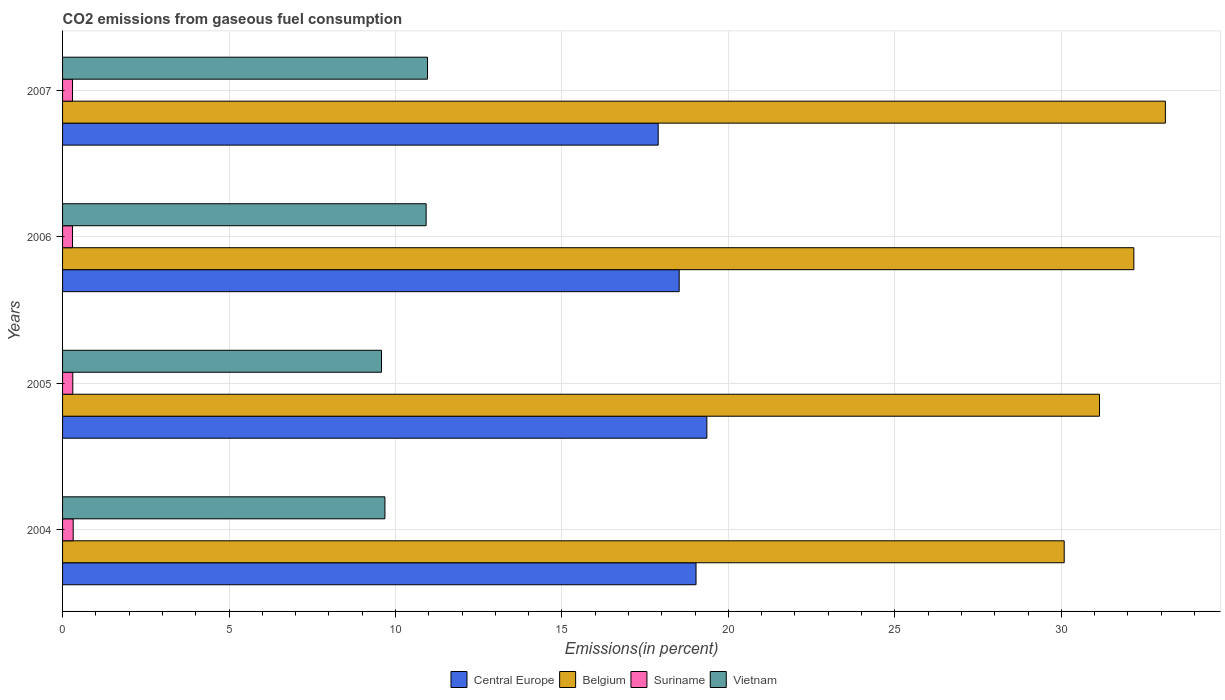How many groups of bars are there?
Your response must be concise. 4. How many bars are there on the 2nd tick from the top?
Provide a short and direct response. 4. What is the label of the 3rd group of bars from the top?
Your answer should be compact. 2005. In how many cases, is the number of bars for a given year not equal to the number of legend labels?
Your answer should be compact. 0. What is the total CO2 emitted in Belgium in 2006?
Your answer should be very brief. 32.18. Across all years, what is the maximum total CO2 emitted in Central Europe?
Make the answer very short. 19.35. Across all years, what is the minimum total CO2 emitted in Suriname?
Your answer should be compact. 0.3. What is the total total CO2 emitted in Suriname in the graph?
Your response must be concise. 1.22. What is the difference between the total CO2 emitted in Suriname in 2005 and that in 2006?
Make the answer very short. 0.01. What is the difference between the total CO2 emitted in Belgium in 2006 and the total CO2 emitted in Central Europe in 2005?
Your answer should be compact. 12.83. What is the average total CO2 emitted in Suriname per year?
Your answer should be very brief. 0.31. In the year 2007, what is the difference between the total CO2 emitted in Central Europe and total CO2 emitted in Belgium?
Keep it short and to the point. -15.23. What is the ratio of the total CO2 emitted in Central Europe in 2004 to that in 2006?
Provide a succinct answer. 1.03. Is the total CO2 emitted in Belgium in 2004 less than that in 2007?
Provide a short and direct response. Yes. What is the difference between the highest and the second highest total CO2 emitted in Suriname?
Offer a terse response. 0.01. What is the difference between the highest and the lowest total CO2 emitted in Central Europe?
Provide a short and direct response. 1.46. In how many years, is the total CO2 emitted in Vietnam greater than the average total CO2 emitted in Vietnam taken over all years?
Offer a very short reply. 2. Is the sum of the total CO2 emitted in Vietnam in 2005 and 2007 greater than the maximum total CO2 emitted in Suriname across all years?
Make the answer very short. Yes. Is it the case that in every year, the sum of the total CO2 emitted in Belgium and total CO2 emitted in Central Europe is greater than the sum of total CO2 emitted in Suriname and total CO2 emitted in Vietnam?
Your response must be concise. No. What does the 4th bar from the top in 2006 represents?
Provide a short and direct response. Central Europe. What does the 4th bar from the bottom in 2005 represents?
Keep it short and to the point. Vietnam. How many bars are there?
Give a very brief answer. 16. What is the difference between two consecutive major ticks on the X-axis?
Provide a short and direct response. 5. Are the values on the major ticks of X-axis written in scientific E-notation?
Make the answer very short. No. Does the graph contain any zero values?
Offer a very short reply. No. Does the graph contain grids?
Make the answer very short. Yes. What is the title of the graph?
Provide a succinct answer. CO2 emissions from gaseous fuel consumption. What is the label or title of the X-axis?
Keep it short and to the point. Emissions(in percent). What is the Emissions(in percent) of Central Europe in 2004?
Provide a short and direct response. 19.03. What is the Emissions(in percent) of Belgium in 2004?
Ensure brevity in your answer.  30.09. What is the Emissions(in percent) in Suriname in 2004?
Ensure brevity in your answer.  0.32. What is the Emissions(in percent) in Vietnam in 2004?
Make the answer very short. 9.68. What is the Emissions(in percent) in Central Europe in 2005?
Provide a succinct answer. 19.35. What is the Emissions(in percent) of Belgium in 2005?
Ensure brevity in your answer.  31.15. What is the Emissions(in percent) of Suriname in 2005?
Your answer should be compact. 0.31. What is the Emissions(in percent) in Vietnam in 2005?
Offer a very short reply. 9.58. What is the Emissions(in percent) of Central Europe in 2006?
Provide a succinct answer. 18.52. What is the Emissions(in percent) of Belgium in 2006?
Your response must be concise. 32.18. What is the Emissions(in percent) in Suriname in 2006?
Provide a succinct answer. 0.3. What is the Emissions(in percent) of Vietnam in 2006?
Your answer should be very brief. 10.92. What is the Emissions(in percent) of Central Europe in 2007?
Provide a succinct answer. 17.89. What is the Emissions(in percent) of Belgium in 2007?
Provide a short and direct response. 33.13. What is the Emissions(in percent) in Suriname in 2007?
Make the answer very short. 0.3. What is the Emissions(in percent) in Vietnam in 2007?
Offer a terse response. 10.96. Across all years, what is the maximum Emissions(in percent) in Central Europe?
Your answer should be compact. 19.35. Across all years, what is the maximum Emissions(in percent) of Belgium?
Your response must be concise. 33.13. Across all years, what is the maximum Emissions(in percent) in Suriname?
Keep it short and to the point. 0.32. Across all years, what is the maximum Emissions(in percent) in Vietnam?
Make the answer very short. 10.96. Across all years, what is the minimum Emissions(in percent) of Central Europe?
Offer a very short reply. 17.89. Across all years, what is the minimum Emissions(in percent) in Belgium?
Your answer should be compact. 30.09. Across all years, what is the minimum Emissions(in percent) in Suriname?
Provide a succinct answer. 0.3. Across all years, what is the minimum Emissions(in percent) in Vietnam?
Your answer should be very brief. 9.58. What is the total Emissions(in percent) in Central Europe in the graph?
Offer a terse response. 74.8. What is the total Emissions(in percent) of Belgium in the graph?
Your answer should be very brief. 126.54. What is the total Emissions(in percent) of Suriname in the graph?
Keep it short and to the point. 1.22. What is the total Emissions(in percent) of Vietnam in the graph?
Offer a terse response. 41.15. What is the difference between the Emissions(in percent) of Central Europe in 2004 and that in 2005?
Make the answer very short. -0.32. What is the difference between the Emissions(in percent) of Belgium in 2004 and that in 2005?
Your response must be concise. -1.06. What is the difference between the Emissions(in percent) in Suriname in 2004 and that in 2005?
Provide a succinct answer. 0.01. What is the difference between the Emissions(in percent) of Vietnam in 2004 and that in 2005?
Provide a succinct answer. 0.1. What is the difference between the Emissions(in percent) of Central Europe in 2004 and that in 2006?
Ensure brevity in your answer.  0.51. What is the difference between the Emissions(in percent) of Belgium in 2004 and that in 2006?
Make the answer very short. -2.09. What is the difference between the Emissions(in percent) in Suriname in 2004 and that in 2006?
Your response must be concise. 0.02. What is the difference between the Emissions(in percent) of Vietnam in 2004 and that in 2006?
Make the answer very short. -1.24. What is the difference between the Emissions(in percent) of Central Europe in 2004 and that in 2007?
Provide a succinct answer. 1.14. What is the difference between the Emissions(in percent) in Belgium in 2004 and that in 2007?
Your answer should be very brief. -3.04. What is the difference between the Emissions(in percent) of Vietnam in 2004 and that in 2007?
Keep it short and to the point. -1.28. What is the difference between the Emissions(in percent) in Central Europe in 2005 and that in 2006?
Offer a terse response. 0.83. What is the difference between the Emissions(in percent) in Belgium in 2005 and that in 2006?
Your response must be concise. -1.03. What is the difference between the Emissions(in percent) of Suriname in 2005 and that in 2006?
Your answer should be compact. 0.01. What is the difference between the Emissions(in percent) in Vietnam in 2005 and that in 2006?
Keep it short and to the point. -1.34. What is the difference between the Emissions(in percent) in Central Europe in 2005 and that in 2007?
Provide a succinct answer. 1.46. What is the difference between the Emissions(in percent) of Belgium in 2005 and that in 2007?
Provide a succinct answer. -1.98. What is the difference between the Emissions(in percent) of Suriname in 2005 and that in 2007?
Keep it short and to the point. 0.01. What is the difference between the Emissions(in percent) of Vietnam in 2005 and that in 2007?
Your response must be concise. -1.38. What is the difference between the Emissions(in percent) of Central Europe in 2006 and that in 2007?
Make the answer very short. 0.63. What is the difference between the Emissions(in percent) in Belgium in 2006 and that in 2007?
Offer a terse response. -0.95. What is the difference between the Emissions(in percent) of Suriname in 2006 and that in 2007?
Your response must be concise. 0. What is the difference between the Emissions(in percent) of Vietnam in 2006 and that in 2007?
Keep it short and to the point. -0.04. What is the difference between the Emissions(in percent) in Central Europe in 2004 and the Emissions(in percent) in Belgium in 2005?
Your answer should be very brief. -12.12. What is the difference between the Emissions(in percent) of Central Europe in 2004 and the Emissions(in percent) of Suriname in 2005?
Provide a short and direct response. 18.72. What is the difference between the Emissions(in percent) of Central Europe in 2004 and the Emissions(in percent) of Vietnam in 2005?
Offer a terse response. 9.45. What is the difference between the Emissions(in percent) of Belgium in 2004 and the Emissions(in percent) of Suriname in 2005?
Your answer should be compact. 29.78. What is the difference between the Emissions(in percent) of Belgium in 2004 and the Emissions(in percent) of Vietnam in 2005?
Provide a short and direct response. 20.51. What is the difference between the Emissions(in percent) in Suriname in 2004 and the Emissions(in percent) in Vietnam in 2005?
Make the answer very short. -9.26. What is the difference between the Emissions(in percent) in Central Europe in 2004 and the Emissions(in percent) in Belgium in 2006?
Your response must be concise. -13.15. What is the difference between the Emissions(in percent) in Central Europe in 2004 and the Emissions(in percent) in Suriname in 2006?
Your response must be concise. 18.73. What is the difference between the Emissions(in percent) of Central Europe in 2004 and the Emissions(in percent) of Vietnam in 2006?
Your response must be concise. 8.11. What is the difference between the Emissions(in percent) in Belgium in 2004 and the Emissions(in percent) in Suriname in 2006?
Make the answer very short. 29.79. What is the difference between the Emissions(in percent) of Belgium in 2004 and the Emissions(in percent) of Vietnam in 2006?
Keep it short and to the point. 19.17. What is the difference between the Emissions(in percent) of Suriname in 2004 and the Emissions(in percent) of Vietnam in 2006?
Ensure brevity in your answer.  -10.6. What is the difference between the Emissions(in percent) of Central Europe in 2004 and the Emissions(in percent) of Belgium in 2007?
Make the answer very short. -14.1. What is the difference between the Emissions(in percent) in Central Europe in 2004 and the Emissions(in percent) in Suriname in 2007?
Offer a very short reply. 18.73. What is the difference between the Emissions(in percent) in Central Europe in 2004 and the Emissions(in percent) in Vietnam in 2007?
Make the answer very short. 8.07. What is the difference between the Emissions(in percent) in Belgium in 2004 and the Emissions(in percent) in Suriname in 2007?
Your answer should be very brief. 29.79. What is the difference between the Emissions(in percent) in Belgium in 2004 and the Emissions(in percent) in Vietnam in 2007?
Your answer should be very brief. 19.12. What is the difference between the Emissions(in percent) of Suriname in 2004 and the Emissions(in percent) of Vietnam in 2007?
Your answer should be very brief. -10.64. What is the difference between the Emissions(in percent) of Central Europe in 2005 and the Emissions(in percent) of Belgium in 2006?
Your answer should be very brief. -12.83. What is the difference between the Emissions(in percent) in Central Europe in 2005 and the Emissions(in percent) in Suriname in 2006?
Provide a short and direct response. 19.05. What is the difference between the Emissions(in percent) in Central Europe in 2005 and the Emissions(in percent) in Vietnam in 2006?
Your answer should be very brief. 8.43. What is the difference between the Emissions(in percent) of Belgium in 2005 and the Emissions(in percent) of Suriname in 2006?
Keep it short and to the point. 30.85. What is the difference between the Emissions(in percent) in Belgium in 2005 and the Emissions(in percent) in Vietnam in 2006?
Provide a short and direct response. 20.23. What is the difference between the Emissions(in percent) of Suriname in 2005 and the Emissions(in percent) of Vietnam in 2006?
Ensure brevity in your answer.  -10.61. What is the difference between the Emissions(in percent) in Central Europe in 2005 and the Emissions(in percent) in Belgium in 2007?
Make the answer very short. -13.77. What is the difference between the Emissions(in percent) of Central Europe in 2005 and the Emissions(in percent) of Suriname in 2007?
Give a very brief answer. 19.05. What is the difference between the Emissions(in percent) of Central Europe in 2005 and the Emissions(in percent) of Vietnam in 2007?
Offer a terse response. 8.39. What is the difference between the Emissions(in percent) of Belgium in 2005 and the Emissions(in percent) of Suriname in 2007?
Your answer should be very brief. 30.85. What is the difference between the Emissions(in percent) of Belgium in 2005 and the Emissions(in percent) of Vietnam in 2007?
Your answer should be compact. 20.19. What is the difference between the Emissions(in percent) of Suriname in 2005 and the Emissions(in percent) of Vietnam in 2007?
Offer a very short reply. -10.66. What is the difference between the Emissions(in percent) of Central Europe in 2006 and the Emissions(in percent) of Belgium in 2007?
Your response must be concise. -14.6. What is the difference between the Emissions(in percent) of Central Europe in 2006 and the Emissions(in percent) of Suriname in 2007?
Offer a very short reply. 18.22. What is the difference between the Emissions(in percent) of Central Europe in 2006 and the Emissions(in percent) of Vietnam in 2007?
Ensure brevity in your answer.  7.56. What is the difference between the Emissions(in percent) in Belgium in 2006 and the Emissions(in percent) in Suriname in 2007?
Your answer should be very brief. 31.88. What is the difference between the Emissions(in percent) of Belgium in 2006 and the Emissions(in percent) of Vietnam in 2007?
Your response must be concise. 21.22. What is the difference between the Emissions(in percent) in Suriname in 2006 and the Emissions(in percent) in Vietnam in 2007?
Offer a terse response. -10.66. What is the average Emissions(in percent) of Central Europe per year?
Your answer should be compact. 18.7. What is the average Emissions(in percent) of Belgium per year?
Provide a succinct answer. 31.64. What is the average Emissions(in percent) of Suriname per year?
Give a very brief answer. 0.31. What is the average Emissions(in percent) of Vietnam per year?
Offer a very short reply. 10.29. In the year 2004, what is the difference between the Emissions(in percent) of Central Europe and Emissions(in percent) of Belgium?
Your answer should be compact. -11.06. In the year 2004, what is the difference between the Emissions(in percent) of Central Europe and Emissions(in percent) of Suriname?
Your answer should be compact. 18.71. In the year 2004, what is the difference between the Emissions(in percent) in Central Europe and Emissions(in percent) in Vietnam?
Make the answer very short. 9.35. In the year 2004, what is the difference between the Emissions(in percent) of Belgium and Emissions(in percent) of Suriname?
Your answer should be compact. 29.77. In the year 2004, what is the difference between the Emissions(in percent) in Belgium and Emissions(in percent) in Vietnam?
Your response must be concise. 20.4. In the year 2004, what is the difference between the Emissions(in percent) of Suriname and Emissions(in percent) of Vietnam?
Give a very brief answer. -9.36. In the year 2005, what is the difference between the Emissions(in percent) in Central Europe and Emissions(in percent) in Belgium?
Make the answer very short. -11.79. In the year 2005, what is the difference between the Emissions(in percent) of Central Europe and Emissions(in percent) of Suriname?
Ensure brevity in your answer.  19.05. In the year 2005, what is the difference between the Emissions(in percent) of Central Europe and Emissions(in percent) of Vietnam?
Provide a short and direct response. 9.77. In the year 2005, what is the difference between the Emissions(in percent) of Belgium and Emissions(in percent) of Suriname?
Make the answer very short. 30.84. In the year 2005, what is the difference between the Emissions(in percent) in Belgium and Emissions(in percent) in Vietnam?
Ensure brevity in your answer.  21.57. In the year 2005, what is the difference between the Emissions(in percent) of Suriname and Emissions(in percent) of Vietnam?
Your answer should be compact. -9.27. In the year 2006, what is the difference between the Emissions(in percent) of Central Europe and Emissions(in percent) of Belgium?
Offer a very short reply. -13.66. In the year 2006, what is the difference between the Emissions(in percent) of Central Europe and Emissions(in percent) of Suriname?
Provide a short and direct response. 18.22. In the year 2006, what is the difference between the Emissions(in percent) of Central Europe and Emissions(in percent) of Vietnam?
Ensure brevity in your answer.  7.6. In the year 2006, what is the difference between the Emissions(in percent) of Belgium and Emissions(in percent) of Suriname?
Ensure brevity in your answer.  31.88. In the year 2006, what is the difference between the Emissions(in percent) in Belgium and Emissions(in percent) in Vietnam?
Ensure brevity in your answer.  21.26. In the year 2006, what is the difference between the Emissions(in percent) of Suriname and Emissions(in percent) of Vietnam?
Offer a very short reply. -10.62. In the year 2007, what is the difference between the Emissions(in percent) in Central Europe and Emissions(in percent) in Belgium?
Offer a very short reply. -15.23. In the year 2007, what is the difference between the Emissions(in percent) of Central Europe and Emissions(in percent) of Suriname?
Your response must be concise. 17.59. In the year 2007, what is the difference between the Emissions(in percent) of Central Europe and Emissions(in percent) of Vietnam?
Offer a very short reply. 6.93. In the year 2007, what is the difference between the Emissions(in percent) in Belgium and Emissions(in percent) in Suriname?
Your answer should be very brief. 32.83. In the year 2007, what is the difference between the Emissions(in percent) in Belgium and Emissions(in percent) in Vietnam?
Make the answer very short. 22.16. In the year 2007, what is the difference between the Emissions(in percent) of Suriname and Emissions(in percent) of Vietnam?
Your answer should be very brief. -10.66. What is the ratio of the Emissions(in percent) in Central Europe in 2004 to that in 2005?
Offer a terse response. 0.98. What is the ratio of the Emissions(in percent) of Suriname in 2004 to that in 2005?
Provide a succinct answer. 1.04. What is the ratio of the Emissions(in percent) of Vietnam in 2004 to that in 2005?
Offer a very short reply. 1.01. What is the ratio of the Emissions(in percent) in Central Europe in 2004 to that in 2006?
Offer a very short reply. 1.03. What is the ratio of the Emissions(in percent) of Belgium in 2004 to that in 2006?
Offer a very short reply. 0.94. What is the ratio of the Emissions(in percent) of Suriname in 2004 to that in 2006?
Offer a terse response. 1.07. What is the ratio of the Emissions(in percent) in Vietnam in 2004 to that in 2006?
Offer a terse response. 0.89. What is the ratio of the Emissions(in percent) in Central Europe in 2004 to that in 2007?
Ensure brevity in your answer.  1.06. What is the ratio of the Emissions(in percent) of Belgium in 2004 to that in 2007?
Your answer should be compact. 0.91. What is the ratio of the Emissions(in percent) in Suriname in 2004 to that in 2007?
Provide a short and direct response. 1.07. What is the ratio of the Emissions(in percent) of Vietnam in 2004 to that in 2007?
Provide a succinct answer. 0.88. What is the ratio of the Emissions(in percent) of Central Europe in 2005 to that in 2006?
Keep it short and to the point. 1.04. What is the ratio of the Emissions(in percent) in Suriname in 2005 to that in 2006?
Provide a short and direct response. 1.03. What is the ratio of the Emissions(in percent) in Vietnam in 2005 to that in 2006?
Make the answer very short. 0.88. What is the ratio of the Emissions(in percent) of Central Europe in 2005 to that in 2007?
Provide a short and direct response. 1.08. What is the ratio of the Emissions(in percent) of Belgium in 2005 to that in 2007?
Keep it short and to the point. 0.94. What is the ratio of the Emissions(in percent) in Suriname in 2005 to that in 2007?
Your answer should be very brief. 1.03. What is the ratio of the Emissions(in percent) of Vietnam in 2005 to that in 2007?
Your answer should be compact. 0.87. What is the ratio of the Emissions(in percent) of Central Europe in 2006 to that in 2007?
Keep it short and to the point. 1.04. What is the ratio of the Emissions(in percent) of Belgium in 2006 to that in 2007?
Offer a terse response. 0.97. What is the ratio of the Emissions(in percent) in Suriname in 2006 to that in 2007?
Provide a short and direct response. 1. What is the difference between the highest and the second highest Emissions(in percent) in Central Europe?
Provide a succinct answer. 0.32. What is the difference between the highest and the second highest Emissions(in percent) in Belgium?
Your answer should be very brief. 0.95. What is the difference between the highest and the second highest Emissions(in percent) of Suriname?
Offer a very short reply. 0.01. What is the difference between the highest and the second highest Emissions(in percent) in Vietnam?
Ensure brevity in your answer.  0.04. What is the difference between the highest and the lowest Emissions(in percent) in Central Europe?
Your response must be concise. 1.46. What is the difference between the highest and the lowest Emissions(in percent) in Belgium?
Your answer should be compact. 3.04. What is the difference between the highest and the lowest Emissions(in percent) in Vietnam?
Ensure brevity in your answer.  1.38. 